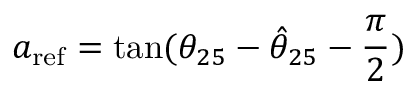Convert formula to latex. <formula><loc_0><loc_0><loc_500><loc_500>a _ { r e f } = \tan ( { \theta _ { 2 5 } - \hat { \theta } _ { 2 5 } - \frac { \pi } { 2 } } )</formula> 